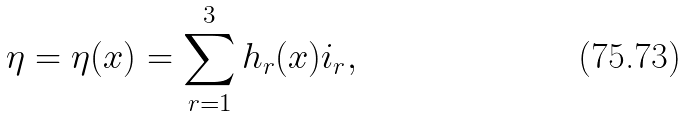<formula> <loc_0><loc_0><loc_500><loc_500>\eta = \eta ( { x } ) = \sum _ { r = 1 } ^ { 3 } h _ { r } ( { x } ) i _ { r } ,</formula> 